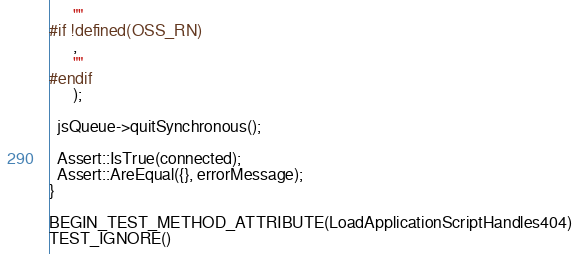Convert code to text. <code><loc_0><loc_0><loc_500><loc_500><_C++_>      ""
#if !defined(OSS_RN)
      ,
      ""
#endif
      );

  jsQueue->quitSynchronous();

  Assert::IsTrue(connected);
  Assert::AreEqual({}, errorMessage);
}

BEGIN_TEST_METHOD_ATTRIBUTE(LoadApplicationScriptHandles404)
TEST_IGNORE()</code> 